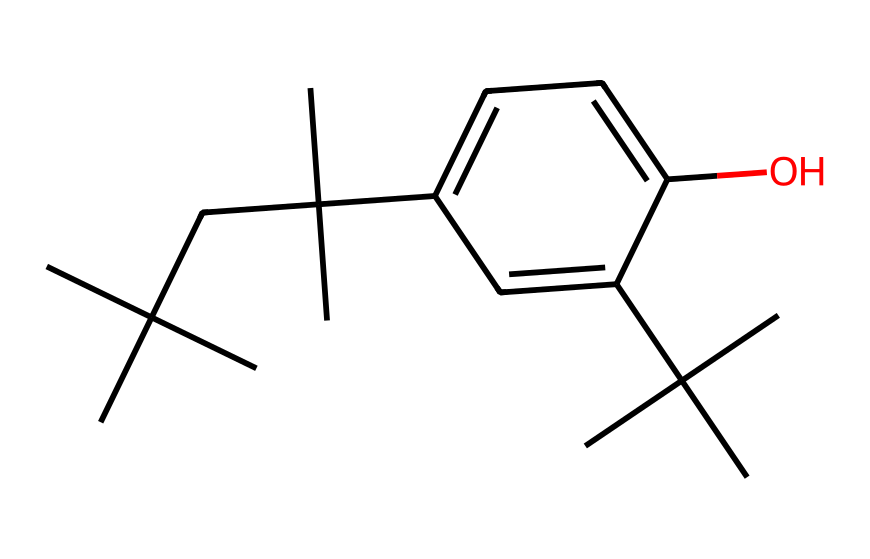What is the primary functional group present in this compound? The chemical structure contains a hydroxyl group (-OH) attached to the aromatic ring, which indicates the presence of a phenolic functional group.
Answer: phenolic How many carbon atoms are present in this molecule? By examining the structure and counting the carbon atoms in the branched and aromatic sections, there are a total of 18 carbon atoms.
Answer: 18 What type of bonding can be inferred from the presence of the aromatic ring in this molecule? The presence of the aromatic ring suggests that there are resonance structures due to delocalized π electrons within the ring, indicating significant covalent bonding characteristics typical of aromatic compounds.
Answer: covalent What is the potential application of this photoresist structure in solar panels? This plant-based photoresist can be used to create patterns on photovoltaic cells, allowing for the formation of necessary structures while being sustainable due to its biobased origin.
Answer: sustainable patterning How many substituents are present on the aromatic ring? There are two substituents on the aromatic ring: one hydroxyl group and one branched carbon chain substituent, indicating the positions of substitution on the ring.
Answer: 2 Which feature in the structure contributes to its biodegradability? The structure is predominantly made up of plant-derived components, including the hydroxyl group and branched aliphatic chains, which are generally more biodegradable compared to synthetic polymers.
Answer: plant-derived components How does the branching in this molecule affect its viscosity during application as a photoresist? The branching contributes to a higher molecular weight and can lead to increased viscosity, which can enhance the film-forming properties and stability during manufacturing processes.
Answer: increased viscosity 